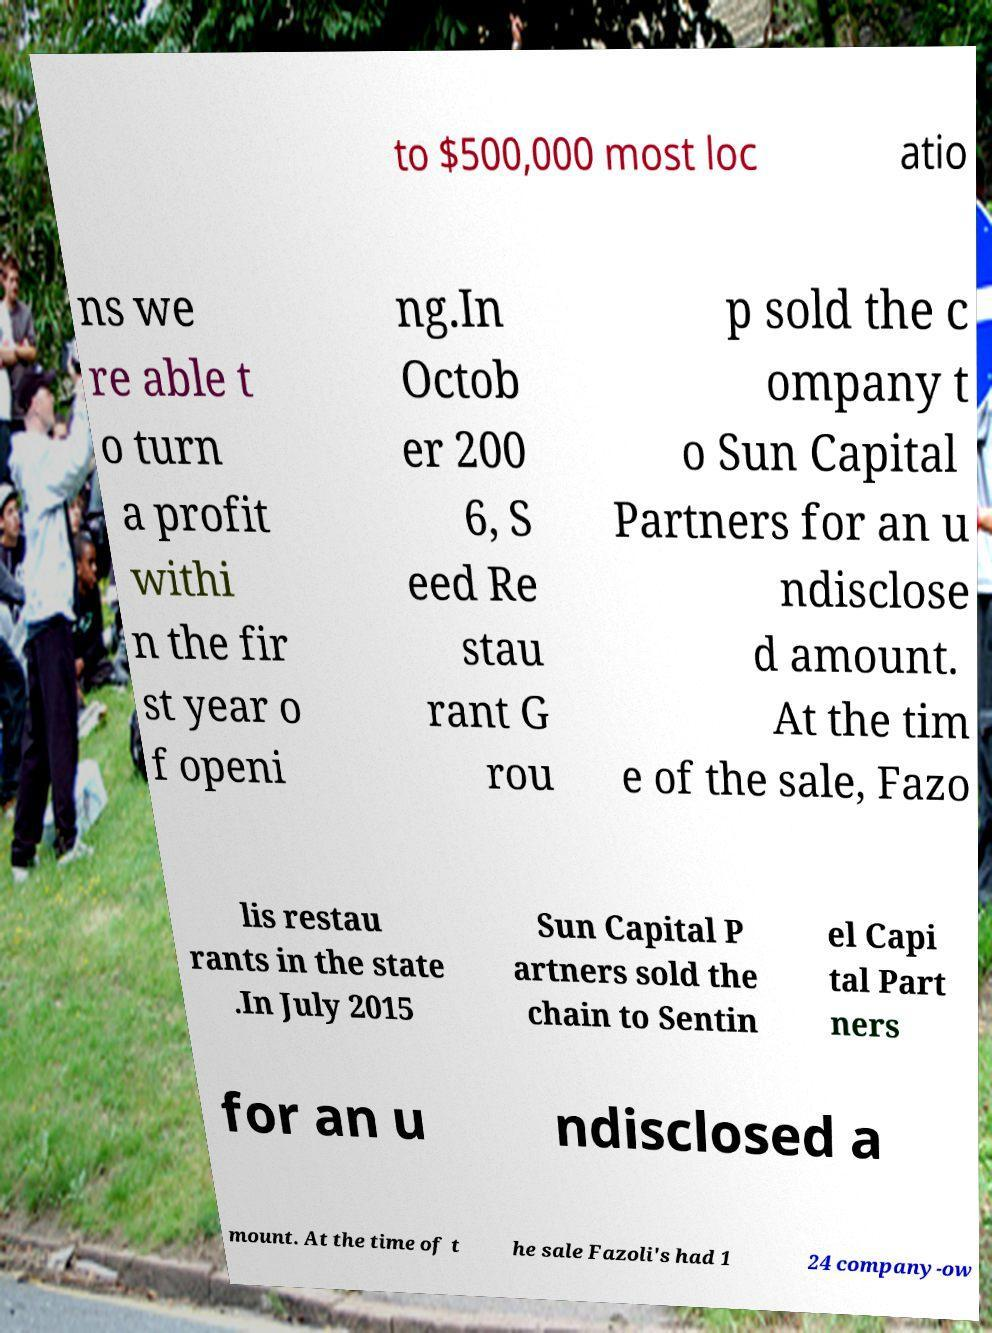Can you accurately transcribe the text from the provided image for me? to $500,000 most loc atio ns we re able t o turn a profit withi n the fir st year o f openi ng.In Octob er 200 6, S eed Re stau rant G rou p sold the c ompany t o Sun Capital Partners for an u ndisclose d amount. At the tim e of the sale, Fazo lis restau rants in the state .In July 2015 Sun Capital P artners sold the chain to Sentin el Capi tal Part ners for an u ndisclosed a mount. At the time of t he sale Fazoli's had 1 24 company-ow 